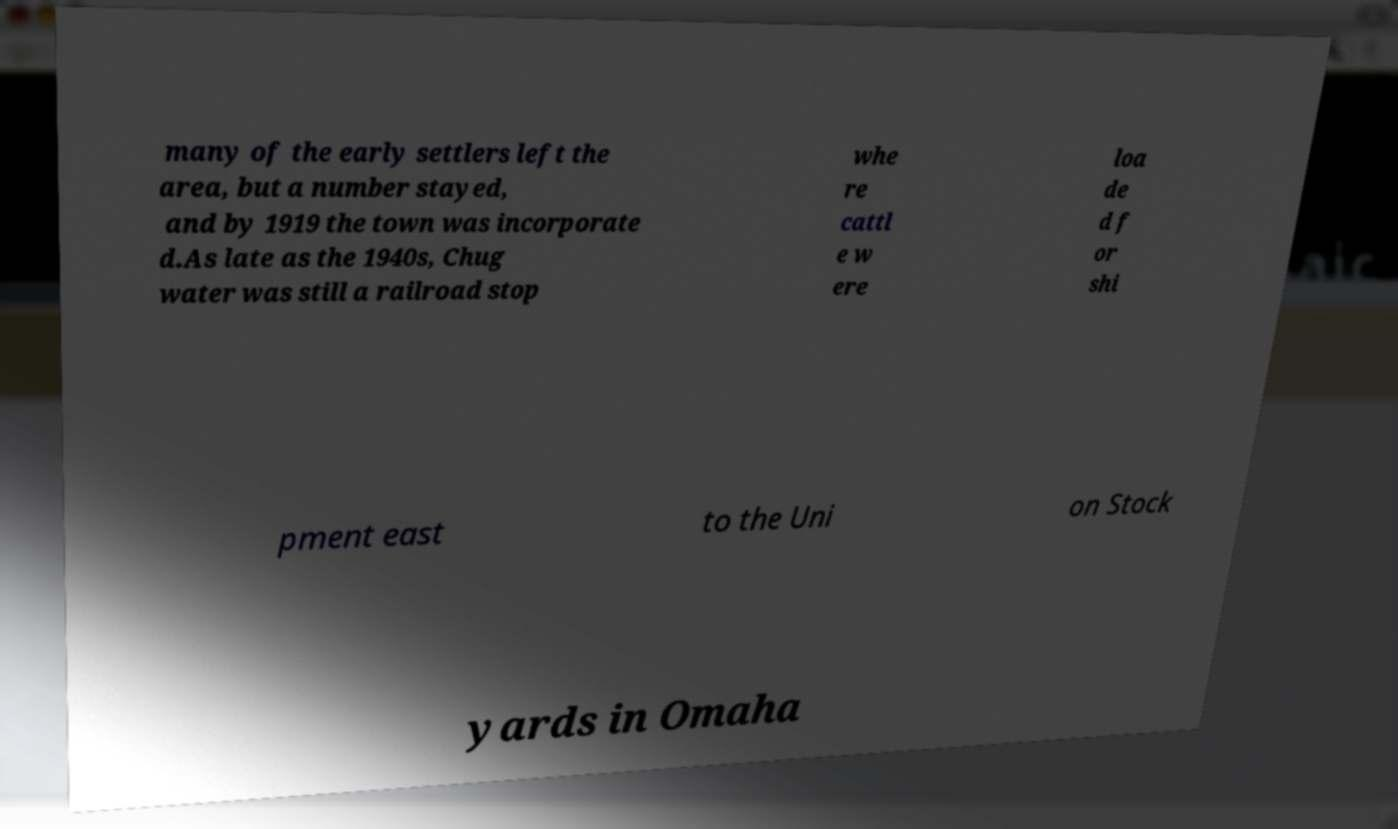Please identify and transcribe the text found in this image. many of the early settlers left the area, but a number stayed, and by 1919 the town was incorporate d.As late as the 1940s, Chug water was still a railroad stop whe re cattl e w ere loa de d f or shi pment east to the Uni on Stock yards in Omaha 